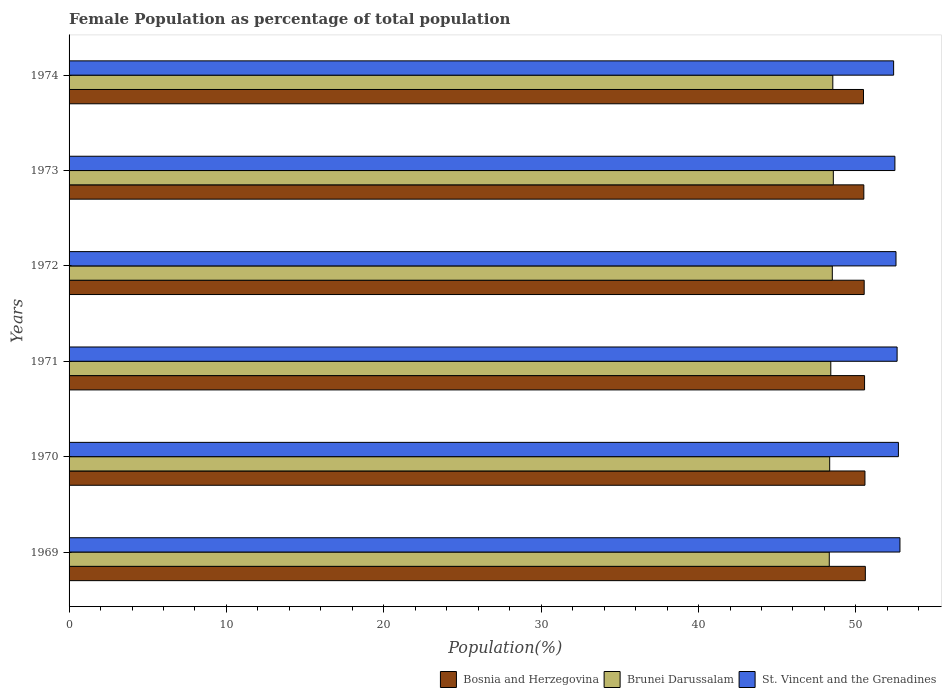How many groups of bars are there?
Ensure brevity in your answer.  6. Are the number of bars on each tick of the Y-axis equal?
Ensure brevity in your answer.  Yes. What is the female population in in Brunei Darussalam in 1972?
Give a very brief answer. 48.5. Across all years, what is the maximum female population in in Brunei Darussalam?
Provide a short and direct response. 48.57. Across all years, what is the minimum female population in in Bosnia and Herzegovina?
Provide a short and direct response. 50.48. In which year was the female population in in Brunei Darussalam maximum?
Your answer should be compact. 1973. In which year was the female population in in St. Vincent and the Grenadines minimum?
Offer a very short reply. 1974. What is the total female population in in St. Vincent and the Grenadines in the graph?
Your answer should be compact. 315.54. What is the difference between the female population in in Brunei Darussalam in 1970 and that in 1974?
Your response must be concise. -0.2. What is the difference between the female population in in Bosnia and Herzegovina in 1971 and the female population in in Brunei Darussalam in 1972?
Your response must be concise. 2.05. What is the average female population in in St. Vincent and the Grenadines per year?
Provide a succinct answer. 52.59. In the year 1969, what is the difference between the female population in in Brunei Darussalam and female population in in Bosnia and Herzegovina?
Offer a very short reply. -2.29. In how many years, is the female population in in St. Vincent and the Grenadines greater than 24 %?
Provide a short and direct response. 6. What is the ratio of the female population in in Brunei Darussalam in 1972 to that in 1973?
Make the answer very short. 1. Is the difference between the female population in in Brunei Darussalam in 1969 and 1972 greater than the difference between the female population in in Bosnia and Herzegovina in 1969 and 1972?
Offer a terse response. No. What is the difference between the highest and the second highest female population in in Bosnia and Herzegovina?
Offer a very short reply. 0.02. What is the difference between the highest and the lowest female population in in St. Vincent and the Grenadines?
Make the answer very short. 0.4. Is the sum of the female population in in Brunei Darussalam in 1970 and 1973 greater than the maximum female population in in Bosnia and Herzegovina across all years?
Provide a short and direct response. Yes. What does the 3rd bar from the top in 1970 represents?
Your answer should be very brief. Bosnia and Herzegovina. What does the 2nd bar from the bottom in 1969 represents?
Your answer should be very brief. Brunei Darussalam. How many years are there in the graph?
Keep it short and to the point. 6. Does the graph contain any zero values?
Your response must be concise. No. Does the graph contain grids?
Offer a very short reply. No. Where does the legend appear in the graph?
Provide a short and direct response. Bottom right. How many legend labels are there?
Offer a terse response. 3. What is the title of the graph?
Provide a succinct answer. Female Population as percentage of total population. What is the label or title of the X-axis?
Your answer should be very brief. Population(%). What is the Population(%) of Bosnia and Herzegovina in 1969?
Offer a very short reply. 50.6. What is the Population(%) of Brunei Darussalam in 1969?
Ensure brevity in your answer.  48.31. What is the Population(%) of St. Vincent and the Grenadines in 1969?
Your answer should be compact. 52.8. What is the Population(%) in Bosnia and Herzegovina in 1970?
Provide a succinct answer. 50.58. What is the Population(%) of Brunei Darussalam in 1970?
Ensure brevity in your answer.  48.33. What is the Population(%) of St. Vincent and the Grenadines in 1970?
Offer a very short reply. 52.7. What is the Population(%) in Bosnia and Herzegovina in 1971?
Ensure brevity in your answer.  50.55. What is the Population(%) in Brunei Darussalam in 1971?
Keep it short and to the point. 48.4. What is the Population(%) in St. Vincent and the Grenadines in 1971?
Ensure brevity in your answer.  52.62. What is the Population(%) of Bosnia and Herzegovina in 1972?
Your answer should be very brief. 50.53. What is the Population(%) in Brunei Darussalam in 1972?
Provide a succinct answer. 48.5. What is the Population(%) in St. Vincent and the Grenadines in 1972?
Keep it short and to the point. 52.55. What is the Population(%) in Bosnia and Herzegovina in 1973?
Ensure brevity in your answer.  50.5. What is the Population(%) in Brunei Darussalam in 1973?
Your response must be concise. 48.57. What is the Population(%) in St. Vincent and the Grenadines in 1973?
Make the answer very short. 52.48. What is the Population(%) in Bosnia and Herzegovina in 1974?
Give a very brief answer. 50.48. What is the Population(%) in Brunei Darussalam in 1974?
Provide a succinct answer. 48.53. What is the Population(%) of St. Vincent and the Grenadines in 1974?
Your answer should be compact. 52.4. Across all years, what is the maximum Population(%) in Bosnia and Herzegovina?
Your response must be concise. 50.6. Across all years, what is the maximum Population(%) of Brunei Darussalam?
Keep it short and to the point. 48.57. Across all years, what is the maximum Population(%) of St. Vincent and the Grenadines?
Ensure brevity in your answer.  52.8. Across all years, what is the minimum Population(%) of Bosnia and Herzegovina?
Give a very brief answer. 50.48. Across all years, what is the minimum Population(%) of Brunei Darussalam?
Offer a terse response. 48.31. Across all years, what is the minimum Population(%) in St. Vincent and the Grenadines?
Your answer should be compact. 52.4. What is the total Population(%) of Bosnia and Herzegovina in the graph?
Provide a short and direct response. 303.24. What is the total Population(%) of Brunei Darussalam in the graph?
Your answer should be very brief. 290.65. What is the total Population(%) of St. Vincent and the Grenadines in the graph?
Give a very brief answer. 315.54. What is the difference between the Population(%) in Bosnia and Herzegovina in 1969 and that in 1970?
Offer a terse response. 0.02. What is the difference between the Population(%) of Brunei Darussalam in 1969 and that in 1970?
Give a very brief answer. -0.03. What is the difference between the Population(%) in St. Vincent and the Grenadines in 1969 and that in 1970?
Keep it short and to the point. 0.1. What is the difference between the Population(%) of Bosnia and Herzegovina in 1969 and that in 1971?
Provide a succinct answer. 0.05. What is the difference between the Population(%) of Brunei Darussalam in 1969 and that in 1971?
Provide a succinct answer. -0.1. What is the difference between the Population(%) in St. Vincent and the Grenadines in 1969 and that in 1971?
Make the answer very short. 0.18. What is the difference between the Population(%) of Bosnia and Herzegovina in 1969 and that in 1972?
Your response must be concise. 0.07. What is the difference between the Population(%) in Brunei Darussalam in 1969 and that in 1972?
Ensure brevity in your answer.  -0.19. What is the difference between the Population(%) in St. Vincent and the Grenadines in 1969 and that in 1972?
Your answer should be very brief. 0.25. What is the difference between the Population(%) in Bosnia and Herzegovina in 1969 and that in 1973?
Offer a terse response. 0.1. What is the difference between the Population(%) of Brunei Darussalam in 1969 and that in 1973?
Provide a succinct answer. -0.26. What is the difference between the Population(%) in St. Vincent and the Grenadines in 1969 and that in 1973?
Offer a terse response. 0.32. What is the difference between the Population(%) in Bosnia and Herzegovina in 1969 and that in 1974?
Ensure brevity in your answer.  0.12. What is the difference between the Population(%) in Brunei Darussalam in 1969 and that in 1974?
Offer a very short reply. -0.22. What is the difference between the Population(%) of St. Vincent and the Grenadines in 1969 and that in 1974?
Provide a succinct answer. 0.4. What is the difference between the Population(%) in Bosnia and Herzegovina in 1970 and that in 1971?
Keep it short and to the point. 0.02. What is the difference between the Population(%) in Brunei Darussalam in 1970 and that in 1971?
Provide a succinct answer. -0.07. What is the difference between the Population(%) in St. Vincent and the Grenadines in 1970 and that in 1971?
Provide a short and direct response. 0.08. What is the difference between the Population(%) of Bosnia and Herzegovina in 1970 and that in 1972?
Keep it short and to the point. 0.05. What is the difference between the Population(%) in Brunei Darussalam in 1970 and that in 1972?
Provide a short and direct response. -0.17. What is the difference between the Population(%) in St. Vincent and the Grenadines in 1970 and that in 1972?
Provide a succinct answer. 0.15. What is the difference between the Population(%) in Bosnia and Herzegovina in 1970 and that in 1973?
Offer a terse response. 0.07. What is the difference between the Population(%) in Brunei Darussalam in 1970 and that in 1973?
Keep it short and to the point. -0.23. What is the difference between the Population(%) of St. Vincent and the Grenadines in 1970 and that in 1973?
Make the answer very short. 0.22. What is the difference between the Population(%) of Bosnia and Herzegovina in 1970 and that in 1974?
Offer a terse response. 0.09. What is the difference between the Population(%) in Brunei Darussalam in 1970 and that in 1974?
Your answer should be compact. -0.2. What is the difference between the Population(%) of St. Vincent and the Grenadines in 1970 and that in 1974?
Provide a succinct answer. 0.3. What is the difference between the Population(%) of Bosnia and Herzegovina in 1971 and that in 1972?
Provide a succinct answer. 0.02. What is the difference between the Population(%) of Brunei Darussalam in 1971 and that in 1972?
Give a very brief answer. -0.1. What is the difference between the Population(%) of St. Vincent and the Grenadines in 1971 and that in 1972?
Make the answer very short. 0.07. What is the difference between the Population(%) of Bosnia and Herzegovina in 1971 and that in 1973?
Provide a succinct answer. 0.05. What is the difference between the Population(%) of Brunei Darussalam in 1971 and that in 1973?
Your answer should be compact. -0.16. What is the difference between the Population(%) in St. Vincent and the Grenadines in 1971 and that in 1973?
Offer a very short reply. 0.14. What is the difference between the Population(%) of Bosnia and Herzegovina in 1971 and that in 1974?
Ensure brevity in your answer.  0.07. What is the difference between the Population(%) in Brunei Darussalam in 1971 and that in 1974?
Offer a terse response. -0.13. What is the difference between the Population(%) of St. Vincent and the Grenadines in 1971 and that in 1974?
Keep it short and to the point. 0.22. What is the difference between the Population(%) of Bosnia and Herzegovina in 1972 and that in 1973?
Make the answer very short. 0.02. What is the difference between the Population(%) of Brunei Darussalam in 1972 and that in 1973?
Provide a succinct answer. -0.06. What is the difference between the Population(%) of St. Vincent and the Grenadines in 1972 and that in 1973?
Ensure brevity in your answer.  0.07. What is the difference between the Population(%) of Bosnia and Herzegovina in 1972 and that in 1974?
Ensure brevity in your answer.  0.04. What is the difference between the Population(%) in Brunei Darussalam in 1972 and that in 1974?
Offer a terse response. -0.03. What is the difference between the Population(%) of St. Vincent and the Grenadines in 1972 and that in 1974?
Make the answer very short. 0.15. What is the difference between the Population(%) in Bosnia and Herzegovina in 1973 and that in 1974?
Make the answer very short. 0.02. What is the difference between the Population(%) in Brunei Darussalam in 1973 and that in 1974?
Your answer should be compact. 0.03. What is the difference between the Population(%) in St. Vincent and the Grenadines in 1973 and that in 1974?
Your response must be concise. 0.08. What is the difference between the Population(%) of Bosnia and Herzegovina in 1969 and the Population(%) of Brunei Darussalam in 1970?
Your answer should be compact. 2.27. What is the difference between the Population(%) in Bosnia and Herzegovina in 1969 and the Population(%) in St. Vincent and the Grenadines in 1970?
Give a very brief answer. -2.1. What is the difference between the Population(%) in Brunei Darussalam in 1969 and the Population(%) in St. Vincent and the Grenadines in 1970?
Provide a succinct answer. -4.39. What is the difference between the Population(%) in Bosnia and Herzegovina in 1969 and the Population(%) in Brunei Darussalam in 1971?
Make the answer very short. 2.2. What is the difference between the Population(%) in Bosnia and Herzegovina in 1969 and the Population(%) in St. Vincent and the Grenadines in 1971?
Make the answer very short. -2.02. What is the difference between the Population(%) of Brunei Darussalam in 1969 and the Population(%) of St. Vincent and the Grenadines in 1971?
Your response must be concise. -4.31. What is the difference between the Population(%) of Bosnia and Herzegovina in 1969 and the Population(%) of Brunei Darussalam in 1972?
Your answer should be compact. 2.1. What is the difference between the Population(%) in Bosnia and Herzegovina in 1969 and the Population(%) in St. Vincent and the Grenadines in 1972?
Keep it short and to the point. -1.95. What is the difference between the Population(%) of Brunei Darussalam in 1969 and the Population(%) of St. Vincent and the Grenadines in 1972?
Provide a short and direct response. -4.24. What is the difference between the Population(%) in Bosnia and Herzegovina in 1969 and the Population(%) in Brunei Darussalam in 1973?
Your answer should be compact. 2.03. What is the difference between the Population(%) of Bosnia and Herzegovina in 1969 and the Population(%) of St. Vincent and the Grenadines in 1973?
Offer a terse response. -1.88. What is the difference between the Population(%) of Brunei Darussalam in 1969 and the Population(%) of St. Vincent and the Grenadines in 1973?
Offer a very short reply. -4.17. What is the difference between the Population(%) of Bosnia and Herzegovina in 1969 and the Population(%) of Brunei Darussalam in 1974?
Your response must be concise. 2.07. What is the difference between the Population(%) of Bosnia and Herzegovina in 1969 and the Population(%) of St. Vincent and the Grenadines in 1974?
Provide a succinct answer. -1.8. What is the difference between the Population(%) of Brunei Darussalam in 1969 and the Population(%) of St. Vincent and the Grenadines in 1974?
Provide a succinct answer. -4.09. What is the difference between the Population(%) of Bosnia and Herzegovina in 1970 and the Population(%) of Brunei Darussalam in 1971?
Your response must be concise. 2.17. What is the difference between the Population(%) in Bosnia and Herzegovina in 1970 and the Population(%) in St. Vincent and the Grenadines in 1971?
Your answer should be very brief. -2.04. What is the difference between the Population(%) in Brunei Darussalam in 1970 and the Population(%) in St. Vincent and the Grenadines in 1971?
Make the answer very short. -4.28. What is the difference between the Population(%) in Bosnia and Herzegovina in 1970 and the Population(%) in Brunei Darussalam in 1972?
Your answer should be very brief. 2.07. What is the difference between the Population(%) of Bosnia and Herzegovina in 1970 and the Population(%) of St. Vincent and the Grenadines in 1972?
Keep it short and to the point. -1.97. What is the difference between the Population(%) of Brunei Darussalam in 1970 and the Population(%) of St. Vincent and the Grenadines in 1972?
Offer a terse response. -4.21. What is the difference between the Population(%) in Bosnia and Herzegovina in 1970 and the Population(%) in Brunei Darussalam in 1973?
Provide a short and direct response. 2.01. What is the difference between the Population(%) of Bosnia and Herzegovina in 1970 and the Population(%) of St. Vincent and the Grenadines in 1973?
Give a very brief answer. -1.9. What is the difference between the Population(%) of Brunei Darussalam in 1970 and the Population(%) of St. Vincent and the Grenadines in 1973?
Ensure brevity in your answer.  -4.14. What is the difference between the Population(%) in Bosnia and Herzegovina in 1970 and the Population(%) in Brunei Darussalam in 1974?
Offer a terse response. 2.04. What is the difference between the Population(%) of Bosnia and Herzegovina in 1970 and the Population(%) of St. Vincent and the Grenadines in 1974?
Your answer should be very brief. -1.82. What is the difference between the Population(%) of Brunei Darussalam in 1970 and the Population(%) of St. Vincent and the Grenadines in 1974?
Provide a short and direct response. -4.06. What is the difference between the Population(%) in Bosnia and Herzegovina in 1971 and the Population(%) in Brunei Darussalam in 1972?
Provide a short and direct response. 2.05. What is the difference between the Population(%) of Bosnia and Herzegovina in 1971 and the Population(%) of St. Vincent and the Grenadines in 1972?
Keep it short and to the point. -2. What is the difference between the Population(%) of Brunei Darussalam in 1971 and the Population(%) of St. Vincent and the Grenadines in 1972?
Your answer should be very brief. -4.14. What is the difference between the Population(%) in Bosnia and Herzegovina in 1971 and the Population(%) in Brunei Darussalam in 1973?
Your answer should be very brief. 1.99. What is the difference between the Population(%) of Bosnia and Herzegovina in 1971 and the Population(%) of St. Vincent and the Grenadines in 1973?
Offer a terse response. -1.93. What is the difference between the Population(%) of Brunei Darussalam in 1971 and the Population(%) of St. Vincent and the Grenadines in 1973?
Offer a very short reply. -4.07. What is the difference between the Population(%) in Bosnia and Herzegovina in 1971 and the Population(%) in Brunei Darussalam in 1974?
Provide a short and direct response. 2.02. What is the difference between the Population(%) in Bosnia and Herzegovina in 1971 and the Population(%) in St. Vincent and the Grenadines in 1974?
Give a very brief answer. -1.85. What is the difference between the Population(%) of Brunei Darussalam in 1971 and the Population(%) of St. Vincent and the Grenadines in 1974?
Ensure brevity in your answer.  -3.99. What is the difference between the Population(%) of Bosnia and Herzegovina in 1972 and the Population(%) of Brunei Darussalam in 1973?
Provide a short and direct response. 1.96. What is the difference between the Population(%) in Bosnia and Herzegovina in 1972 and the Population(%) in St. Vincent and the Grenadines in 1973?
Offer a terse response. -1.95. What is the difference between the Population(%) of Brunei Darussalam in 1972 and the Population(%) of St. Vincent and the Grenadines in 1973?
Ensure brevity in your answer.  -3.98. What is the difference between the Population(%) in Bosnia and Herzegovina in 1972 and the Population(%) in Brunei Darussalam in 1974?
Provide a short and direct response. 1.99. What is the difference between the Population(%) in Bosnia and Herzegovina in 1972 and the Population(%) in St. Vincent and the Grenadines in 1974?
Make the answer very short. -1.87. What is the difference between the Population(%) in Brunei Darussalam in 1972 and the Population(%) in St. Vincent and the Grenadines in 1974?
Offer a very short reply. -3.9. What is the difference between the Population(%) in Bosnia and Herzegovina in 1973 and the Population(%) in Brunei Darussalam in 1974?
Offer a very short reply. 1.97. What is the difference between the Population(%) in Bosnia and Herzegovina in 1973 and the Population(%) in St. Vincent and the Grenadines in 1974?
Offer a very short reply. -1.89. What is the difference between the Population(%) of Brunei Darussalam in 1973 and the Population(%) of St. Vincent and the Grenadines in 1974?
Offer a terse response. -3.83. What is the average Population(%) of Bosnia and Herzegovina per year?
Give a very brief answer. 50.54. What is the average Population(%) of Brunei Darussalam per year?
Your response must be concise. 48.44. What is the average Population(%) in St. Vincent and the Grenadines per year?
Provide a short and direct response. 52.59. In the year 1969, what is the difference between the Population(%) of Bosnia and Herzegovina and Population(%) of Brunei Darussalam?
Provide a short and direct response. 2.29. In the year 1969, what is the difference between the Population(%) of Bosnia and Herzegovina and Population(%) of St. Vincent and the Grenadines?
Make the answer very short. -2.2. In the year 1969, what is the difference between the Population(%) in Brunei Darussalam and Population(%) in St. Vincent and the Grenadines?
Offer a very short reply. -4.49. In the year 1970, what is the difference between the Population(%) in Bosnia and Herzegovina and Population(%) in Brunei Darussalam?
Your answer should be very brief. 2.24. In the year 1970, what is the difference between the Population(%) of Bosnia and Herzegovina and Population(%) of St. Vincent and the Grenadines?
Keep it short and to the point. -2.13. In the year 1970, what is the difference between the Population(%) in Brunei Darussalam and Population(%) in St. Vincent and the Grenadines?
Make the answer very short. -4.37. In the year 1971, what is the difference between the Population(%) in Bosnia and Herzegovina and Population(%) in Brunei Darussalam?
Give a very brief answer. 2.15. In the year 1971, what is the difference between the Population(%) in Bosnia and Herzegovina and Population(%) in St. Vincent and the Grenadines?
Keep it short and to the point. -2.07. In the year 1971, what is the difference between the Population(%) of Brunei Darussalam and Population(%) of St. Vincent and the Grenadines?
Your answer should be very brief. -4.21. In the year 1972, what is the difference between the Population(%) in Bosnia and Herzegovina and Population(%) in Brunei Darussalam?
Your answer should be very brief. 2.03. In the year 1972, what is the difference between the Population(%) in Bosnia and Herzegovina and Population(%) in St. Vincent and the Grenadines?
Make the answer very short. -2.02. In the year 1972, what is the difference between the Population(%) in Brunei Darussalam and Population(%) in St. Vincent and the Grenadines?
Keep it short and to the point. -4.05. In the year 1973, what is the difference between the Population(%) in Bosnia and Herzegovina and Population(%) in Brunei Darussalam?
Make the answer very short. 1.94. In the year 1973, what is the difference between the Population(%) in Bosnia and Herzegovina and Population(%) in St. Vincent and the Grenadines?
Keep it short and to the point. -1.97. In the year 1973, what is the difference between the Population(%) in Brunei Darussalam and Population(%) in St. Vincent and the Grenadines?
Ensure brevity in your answer.  -3.91. In the year 1974, what is the difference between the Population(%) of Bosnia and Herzegovina and Population(%) of Brunei Darussalam?
Your response must be concise. 1.95. In the year 1974, what is the difference between the Population(%) of Bosnia and Herzegovina and Population(%) of St. Vincent and the Grenadines?
Your answer should be very brief. -1.91. In the year 1974, what is the difference between the Population(%) of Brunei Darussalam and Population(%) of St. Vincent and the Grenadines?
Provide a succinct answer. -3.86. What is the ratio of the Population(%) in Bosnia and Herzegovina in 1969 to that in 1970?
Ensure brevity in your answer.  1. What is the ratio of the Population(%) in Brunei Darussalam in 1969 to that in 1970?
Give a very brief answer. 1. What is the ratio of the Population(%) in St. Vincent and the Grenadines in 1969 to that in 1970?
Your answer should be very brief. 1. What is the ratio of the Population(%) in Bosnia and Herzegovina in 1969 to that in 1971?
Ensure brevity in your answer.  1. What is the ratio of the Population(%) in Brunei Darussalam in 1969 to that in 1971?
Provide a short and direct response. 1. What is the ratio of the Population(%) of St. Vincent and the Grenadines in 1969 to that in 1971?
Provide a succinct answer. 1. What is the ratio of the Population(%) of Bosnia and Herzegovina in 1969 to that in 1972?
Your answer should be compact. 1. What is the ratio of the Population(%) of Brunei Darussalam in 1969 to that in 1972?
Provide a short and direct response. 1. What is the ratio of the Population(%) in St. Vincent and the Grenadines in 1969 to that in 1972?
Make the answer very short. 1. What is the ratio of the Population(%) of Bosnia and Herzegovina in 1969 to that in 1973?
Keep it short and to the point. 1. What is the ratio of the Population(%) in Brunei Darussalam in 1969 to that in 1973?
Ensure brevity in your answer.  0.99. What is the ratio of the Population(%) of St. Vincent and the Grenadines in 1969 to that in 1973?
Offer a terse response. 1.01. What is the ratio of the Population(%) of St. Vincent and the Grenadines in 1969 to that in 1974?
Your response must be concise. 1.01. What is the ratio of the Population(%) of Brunei Darussalam in 1970 to that in 1972?
Your response must be concise. 1. What is the ratio of the Population(%) of St. Vincent and the Grenadines in 1970 to that in 1972?
Keep it short and to the point. 1. What is the ratio of the Population(%) of St. Vincent and the Grenadines in 1970 to that in 1973?
Offer a terse response. 1. What is the ratio of the Population(%) of Brunei Darussalam in 1970 to that in 1974?
Give a very brief answer. 1. What is the ratio of the Population(%) of St. Vincent and the Grenadines in 1970 to that in 1974?
Keep it short and to the point. 1.01. What is the ratio of the Population(%) of Bosnia and Herzegovina in 1971 to that in 1972?
Give a very brief answer. 1. What is the ratio of the Population(%) in Bosnia and Herzegovina in 1971 to that in 1973?
Offer a terse response. 1. What is the ratio of the Population(%) of Brunei Darussalam in 1971 to that in 1973?
Ensure brevity in your answer.  1. What is the ratio of the Population(%) in Bosnia and Herzegovina in 1971 to that in 1974?
Provide a succinct answer. 1. What is the ratio of the Population(%) in Bosnia and Herzegovina in 1972 to that in 1973?
Keep it short and to the point. 1. What is the ratio of the Population(%) of Brunei Darussalam in 1972 to that in 1974?
Your response must be concise. 1. What is the ratio of the Population(%) in Bosnia and Herzegovina in 1973 to that in 1974?
Provide a succinct answer. 1. What is the difference between the highest and the second highest Population(%) in Bosnia and Herzegovina?
Ensure brevity in your answer.  0.02. What is the difference between the highest and the second highest Population(%) of Brunei Darussalam?
Provide a succinct answer. 0.03. What is the difference between the highest and the second highest Population(%) in St. Vincent and the Grenadines?
Offer a terse response. 0.1. What is the difference between the highest and the lowest Population(%) in Bosnia and Herzegovina?
Provide a short and direct response. 0.12. What is the difference between the highest and the lowest Population(%) of Brunei Darussalam?
Your answer should be compact. 0.26. What is the difference between the highest and the lowest Population(%) of St. Vincent and the Grenadines?
Provide a succinct answer. 0.4. 